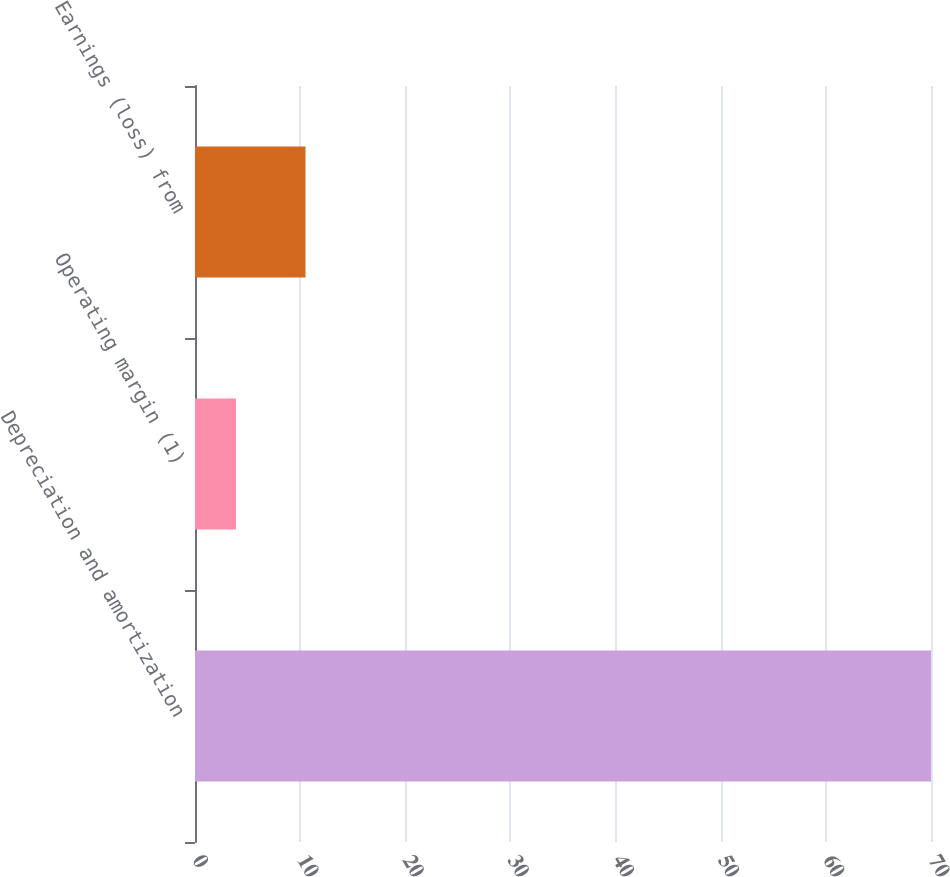<chart> <loc_0><loc_0><loc_500><loc_500><bar_chart><fcel>Depreciation and amortization<fcel>Operating margin (1)<fcel>Earnings (loss) from<nl><fcel>70<fcel>3.9<fcel>10.51<nl></chart> 